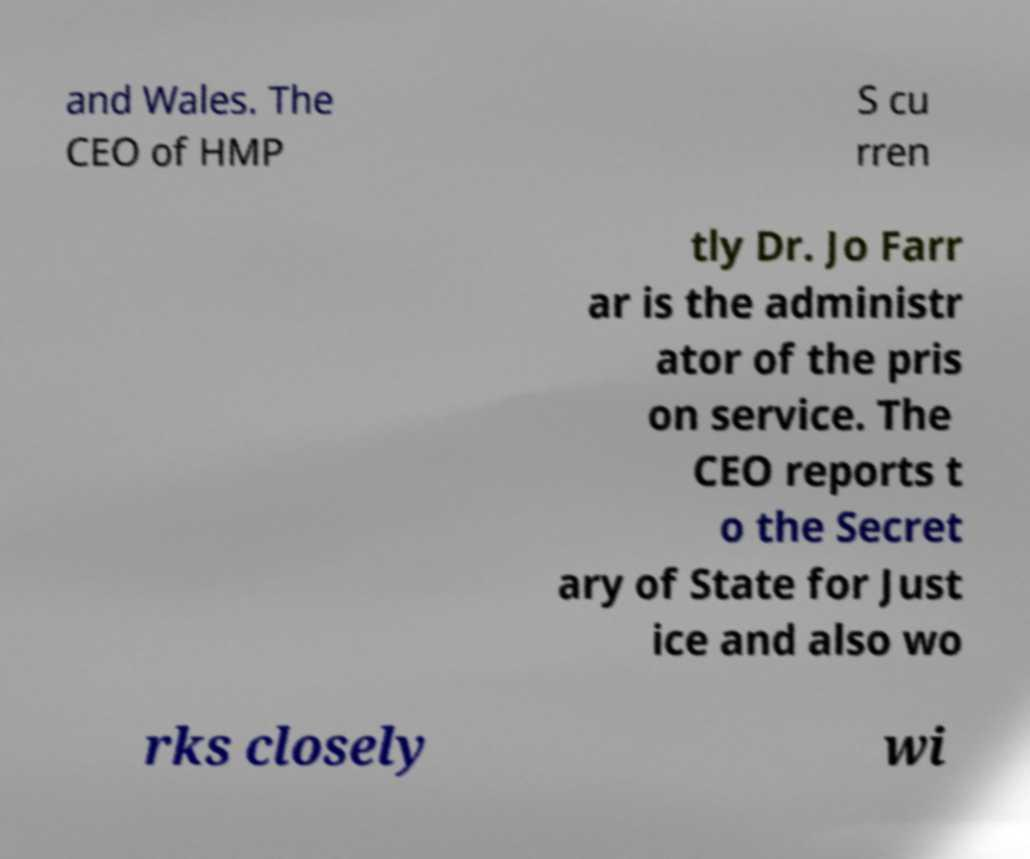For documentation purposes, I need the text within this image transcribed. Could you provide that? and Wales. The CEO of HMP S cu rren tly Dr. Jo Farr ar is the administr ator of the pris on service. The CEO reports t o the Secret ary of State for Just ice and also wo rks closely wi 